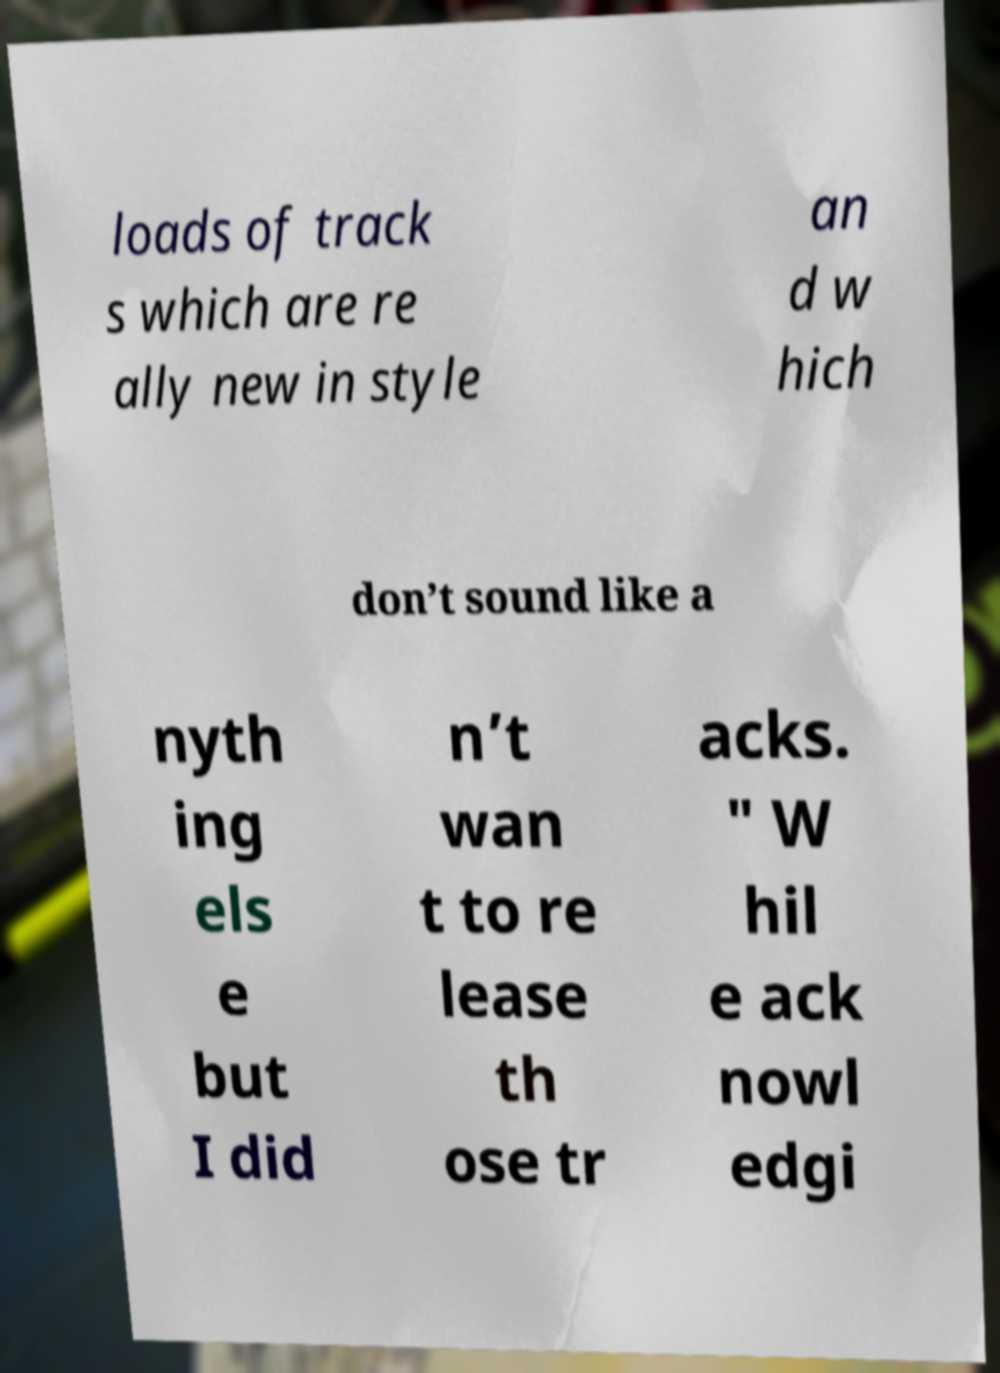Can you accurately transcribe the text from the provided image for me? loads of track s which are re ally new in style an d w hich don’t sound like a nyth ing els e but I did n’t wan t to re lease th ose tr acks. " W hil e ack nowl edgi 